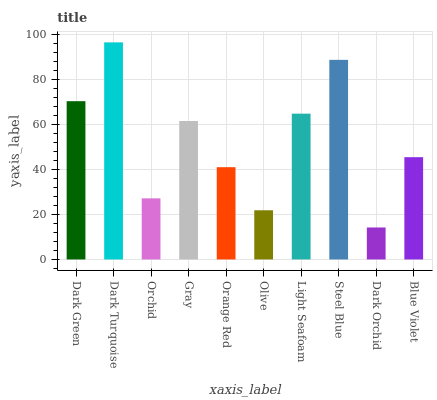Is Dark Orchid the minimum?
Answer yes or no. Yes. Is Dark Turquoise the maximum?
Answer yes or no. Yes. Is Orchid the minimum?
Answer yes or no. No. Is Orchid the maximum?
Answer yes or no. No. Is Dark Turquoise greater than Orchid?
Answer yes or no. Yes. Is Orchid less than Dark Turquoise?
Answer yes or no. Yes. Is Orchid greater than Dark Turquoise?
Answer yes or no. No. Is Dark Turquoise less than Orchid?
Answer yes or no. No. Is Gray the high median?
Answer yes or no. Yes. Is Blue Violet the low median?
Answer yes or no. Yes. Is Orange Red the high median?
Answer yes or no. No. Is Dark Green the low median?
Answer yes or no. No. 